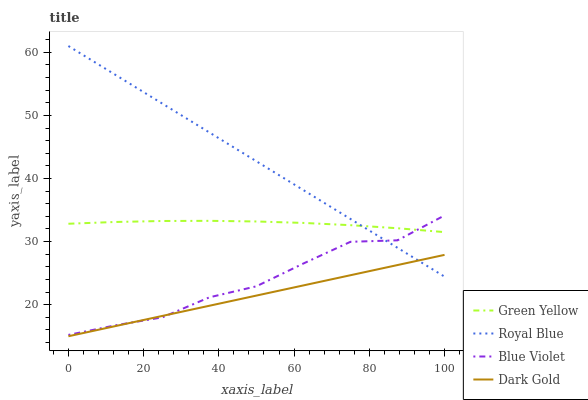Does Dark Gold have the minimum area under the curve?
Answer yes or no. Yes. Does Royal Blue have the maximum area under the curve?
Answer yes or no. Yes. Does Green Yellow have the minimum area under the curve?
Answer yes or no. No. Does Green Yellow have the maximum area under the curve?
Answer yes or no. No. Is Dark Gold the smoothest?
Answer yes or no. Yes. Is Blue Violet the roughest?
Answer yes or no. Yes. Is Green Yellow the smoothest?
Answer yes or no. No. Is Green Yellow the roughest?
Answer yes or no. No. Does Dark Gold have the lowest value?
Answer yes or no. Yes. Does Blue Violet have the lowest value?
Answer yes or no. No. Does Royal Blue have the highest value?
Answer yes or no. Yes. Does Green Yellow have the highest value?
Answer yes or no. No. Is Dark Gold less than Green Yellow?
Answer yes or no. Yes. Is Green Yellow greater than Dark Gold?
Answer yes or no. Yes. Does Green Yellow intersect Blue Violet?
Answer yes or no. Yes. Is Green Yellow less than Blue Violet?
Answer yes or no. No. Is Green Yellow greater than Blue Violet?
Answer yes or no. No. Does Dark Gold intersect Green Yellow?
Answer yes or no. No. 